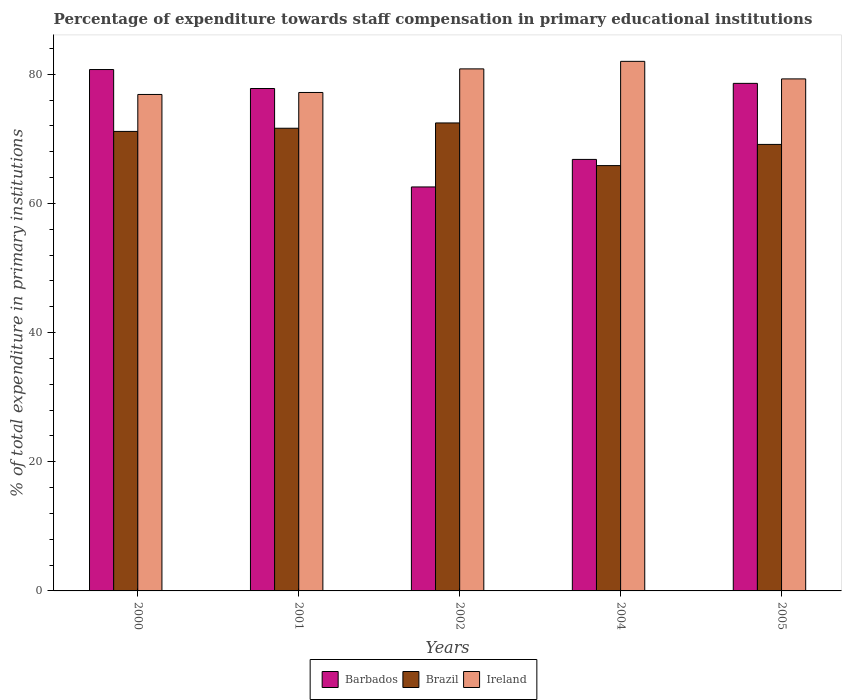How many different coloured bars are there?
Provide a short and direct response. 3. How many groups of bars are there?
Keep it short and to the point. 5. Are the number of bars per tick equal to the number of legend labels?
Provide a succinct answer. Yes. How many bars are there on the 3rd tick from the right?
Offer a very short reply. 3. What is the percentage of expenditure towards staff compensation in Ireland in 2005?
Your answer should be very brief. 79.29. Across all years, what is the maximum percentage of expenditure towards staff compensation in Ireland?
Your answer should be very brief. 82. Across all years, what is the minimum percentage of expenditure towards staff compensation in Brazil?
Offer a terse response. 65.86. In which year was the percentage of expenditure towards staff compensation in Ireland maximum?
Your answer should be compact. 2004. In which year was the percentage of expenditure towards staff compensation in Barbados minimum?
Provide a succinct answer. 2002. What is the total percentage of expenditure towards staff compensation in Ireland in the graph?
Give a very brief answer. 396.19. What is the difference between the percentage of expenditure towards staff compensation in Ireland in 2002 and that in 2005?
Your response must be concise. 1.55. What is the difference between the percentage of expenditure towards staff compensation in Barbados in 2000 and the percentage of expenditure towards staff compensation in Ireland in 2005?
Give a very brief answer. 1.45. What is the average percentage of expenditure towards staff compensation in Brazil per year?
Provide a succinct answer. 70.05. In the year 2001, what is the difference between the percentage of expenditure towards staff compensation in Ireland and percentage of expenditure towards staff compensation in Brazil?
Your response must be concise. 5.54. What is the ratio of the percentage of expenditure towards staff compensation in Brazil in 2004 to that in 2005?
Keep it short and to the point. 0.95. Is the difference between the percentage of expenditure towards staff compensation in Ireland in 2001 and 2004 greater than the difference between the percentage of expenditure towards staff compensation in Brazil in 2001 and 2004?
Ensure brevity in your answer.  No. What is the difference between the highest and the second highest percentage of expenditure towards staff compensation in Barbados?
Keep it short and to the point. 2.14. What is the difference between the highest and the lowest percentage of expenditure towards staff compensation in Brazil?
Keep it short and to the point. 6.6. Is the sum of the percentage of expenditure towards staff compensation in Brazil in 2002 and 2004 greater than the maximum percentage of expenditure towards staff compensation in Ireland across all years?
Provide a succinct answer. Yes. What does the 1st bar from the left in 2005 represents?
Provide a short and direct response. Barbados. How many bars are there?
Your response must be concise. 15. How many years are there in the graph?
Keep it short and to the point. 5. What is the difference between two consecutive major ticks on the Y-axis?
Offer a terse response. 20. Are the values on the major ticks of Y-axis written in scientific E-notation?
Your response must be concise. No. Does the graph contain grids?
Keep it short and to the point. No. Where does the legend appear in the graph?
Provide a short and direct response. Bottom center. How are the legend labels stacked?
Offer a terse response. Horizontal. What is the title of the graph?
Offer a terse response. Percentage of expenditure towards staff compensation in primary educational institutions. What is the label or title of the Y-axis?
Offer a terse response. % of total expenditure in primary institutions. What is the % of total expenditure in primary institutions of Barbados in 2000?
Your answer should be very brief. 80.73. What is the % of total expenditure in primary institutions in Brazil in 2000?
Your answer should be compact. 71.15. What is the % of total expenditure in primary institutions of Ireland in 2000?
Offer a very short reply. 76.88. What is the % of total expenditure in primary institutions in Barbados in 2001?
Ensure brevity in your answer.  77.8. What is the % of total expenditure in primary institutions of Brazil in 2001?
Provide a short and direct response. 71.64. What is the % of total expenditure in primary institutions of Ireland in 2001?
Provide a short and direct response. 77.18. What is the % of total expenditure in primary institutions of Barbados in 2002?
Give a very brief answer. 62.55. What is the % of total expenditure in primary institutions of Brazil in 2002?
Your response must be concise. 72.46. What is the % of total expenditure in primary institutions in Ireland in 2002?
Your answer should be compact. 80.84. What is the % of total expenditure in primary institutions of Barbados in 2004?
Offer a very short reply. 66.82. What is the % of total expenditure in primary institutions of Brazil in 2004?
Your answer should be compact. 65.86. What is the % of total expenditure in primary institutions of Ireland in 2004?
Your response must be concise. 82. What is the % of total expenditure in primary institutions in Barbados in 2005?
Give a very brief answer. 78.59. What is the % of total expenditure in primary institutions in Brazil in 2005?
Your response must be concise. 69.14. What is the % of total expenditure in primary institutions of Ireland in 2005?
Ensure brevity in your answer.  79.29. Across all years, what is the maximum % of total expenditure in primary institutions of Barbados?
Your response must be concise. 80.73. Across all years, what is the maximum % of total expenditure in primary institutions of Brazil?
Provide a succinct answer. 72.46. Across all years, what is the maximum % of total expenditure in primary institutions of Ireland?
Provide a succinct answer. 82. Across all years, what is the minimum % of total expenditure in primary institutions of Barbados?
Your answer should be very brief. 62.55. Across all years, what is the minimum % of total expenditure in primary institutions of Brazil?
Offer a terse response. 65.86. Across all years, what is the minimum % of total expenditure in primary institutions in Ireland?
Ensure brevity in your answer.  76.88. What is the total % of total expenditure in primary institutions in Barbados in the graph?
Provide a short and direct response. 366.5. What is the total % of total expenditure in primary institutions of Brazil in the graph?
Provide a succinct answer. 350.27. What is the total % of total expenditure in primary institutions in Ireland in the graph?
Make the answer very short. 396.19. What is the difference between the % of total expenditure in primary institutions in Barbados in 2000 and that in 2001?
Provide a succinct answer. 2.94. What is the difference between the % of total expenditure in primary institutions of Brazil in 2000 and that in 2001?
Offer a terse response. -0.49. What is the difference between the % of total expenditure in primary institutions in Ireland in 2000 and that in 2001?
Make the answer very short. -0.31. What is the difference between the % of total expenditure in primary institutions in Barbados in 2000 and that in 2002?
Your response must be concise. 18.18. What is the difference between the % of total expenditure in primary institutions of Brazil in 2000 and that in 2002?
Keep it short and to the point. -1.31. What is the difference between the % of total expenditure in primary institutions of Ireland in 2000 and that in 2002?
Ensure brevity in your answer.  -3.96. What is the difference between the % of total expenditure in primary institutions in Barbados in 2000 and that in 2004?
Provide a succinct answer. 13.91. What is the difference between the % of total expenditure in primary institutions of Brazil in 2000 and that in 2004?
Ensure brevity in your answer.  5.29. What is the difference between the % of total expenditure in primary institutions of Ireland in 2000 and that in 2004?
Provide a short and direct response. -5.13. What is the difference between the % of total expenditure in primary institutions in Barbados in 2000 and that in 2005?
Give a very brief answer. 2.14. What is the difference between the % of total expenditure in primary institutions in Brazil in 2000 and that in 2005?
Offer a very short reply. 2.01. What is the difference between the % of total expenditure in primary institutions of Ireland in 2000 and that in 2005?
Ensure brevity in your answer.  -2.41. What is the difference between the % of total expenditure in primary institutions of Barbados in 2001 and that in 2002?
Make the answer very short. 15.24. What is the difference between the % of total expenditure in primary institutions in Brazil in 2001 and that in 2002?
Give a very brief answer. -0.82. What is the difference between the % of total expenditure in primary institutions in Ireland in 2001 and that in 2002?
Provide a succinct answer. -3.65. What is the difference between the % of total expenditure in primary institutions in Barbados in 2001 and that in 2004?
Offer a very short reply. 10.98. What is the difference between the % of total expenditure in primary institutions in Brazil in 2001 and that in 2004?
Offer a very short reply. 5.78. What is the difference between the % of total expenditure in primary institutions in Ireland in 2001 and that in 2004?
Offer a very short reply. -4.82. What is the difference between the % of total expenditure in primary institutions in Barbados in 2001 and that in 2005?
Make the answer very short. -0.8. What is the difference between the % of total expenditure in primary institutions in Brazil in 2001 and that in 2005?
Make the answer very short. 2.5. What is the difference between the % of total expenditure in primary institutions of Ireland in 2001 and that in 2005?
Provide a succinct answer. -2.1. What is the difference between the % of total expenditure in primary institutions of Barbados in 2002 and that in 2004?
Your answer should be compact. -4.26. What is the difference between the % of total expenditure in primary institutions in Brazil in 2002 and that in 2004?
Your answer should be compact. 6.6. What is the difference between the % of total expenditure in primary institutions of Ireland in 2002 and that in 2004?
Provide a short and direct response. -1.17. What is the difference between the % of total expenditure in primary institutions in Barbados in 2002 and that in 2005?
Your response must be concise. -16.04. What is the difference between the % of total expenditure in primary institutions of Brazil in 2002 and that in 2005?
Give a very brief answer. 3.32. What is the difference between the % of total expenditure in primary institutions in Ireland in 2002 and that in 2005?
Ensure brevity in your answer.  1.55. What is the difference between the % of total expenditure in primary institutions in Barbados in 2004 and that in 2005?
Make the answer very short. -11.77. What is the difference between the % of total expenditure in primary institutions in Brazil in 2004 and that in 2005?
Provide a succinct answer. -3.28. What is the difference between the % of total expenditure in primary institutions of Ireland in 2004 and that in 2005?
Keep it short and to the point. 2.72. What is the difference between the % of total expenditure in primary institutions in Barbados in 2000 and the % of total expenditure in primary institutions in Brazil in 2001?
Offer a very short reply. 9.09. What is the difference between the % of total expenditure in primary institutions of Barbados in 2000 and the % of total expenditure in primary institutions of Ireland in 2001?
Offer a very short reply. 3.55. What is the difference between the % of total expenditure in primary institutions in Brazil in 2000 and the % of total expenditure in primary institutions in Ireland in 2001?
Make the answer very short. -6.03. What is the difference between the % of total expenditure in primary institutions of Barbados in 2000 and the % of total expenditure in primary institutions of Brazil in 2002?
Give a very brief answer. 8.27. What is the difference between the % of total expenditure in primary institutions in Barbados in 2000 and the % of total expenditure in primary institutions in Ireland in 2002?
Give a very brief answer. -0.1. What is the difference between the % of total expenditure in primary institutions in Brazil in 2000 and the % of total expenditure in primary institutions in Ireland in 2002?
Your answer should be compact. -9.68. What is the difference between the % of total expenditure in primary institutions in Barbados in 2000 and the % of total expenditure in primary institutions in Brazil in 2004?
Make the answer very short. 14.87. What is the difference between the % of total expenditure in primary institutions in Barbados in 2000 and the % of total expenditure in primary institutions in Ireland in 2004?
Provide a succinct answer. -1.27. What is the difference between the % of total expenditure in primary institutions in Brazil in 2000 and the % of total expenditure in primary institutions in Ireland in 2004?
Provide a short and direct response. -10.85. What is the difference between the % of total expenditure in primary institutions of Barbados in 2000 and the % of total expenditure in primary institutions of Brazil in 2005?
Provide a succinct answer. 11.59. What is the difference between the % of total expenditure in primary institutions of Barbados in 2000 and the % of total expenditure in primary institutions of Ireland in 2005?
Your answer should be compact. 1.45. What is the difference between the % of total expenditure in primary institutions in Brazil in 2000 and the % of total expenditure in primary institutions in Ireland in 2005?
Your answer should be very brief. -8.13. What is the difference between the % of total expenditure in primary institutions in Barbados in 2001 and the % of total expenditure in primary institutions in Brazil in 2002?
Keep it short and to the point. 5.33. What is the difference between the % of total expenditure in primary institutions in Barbados in 2001 and the % of total expenditure in primary institutions in Ireland in 2002?
Your answer should be very brief. -3.04. What is the difference between the % of total expenditure in primary institutions of Brazil in 2001 and the % of total expenditure in primary institutions of Ireland in 2002?
Make the answer very short. -9.19. What is the difference between the % of total expenditure in primary institutions of Barbados in 2001 and the % of total expenditure in primary institutions of Brazil in 2004?
Your answer should be compact. 11.94. What is the difference between the % of total expenditure in primary institutions of Barbados in 2001 and the % of total expenditure in primary institutions of Ireland in 2004?
Keep it short and to the point. -4.2. What is the difference between the % of total expenditure in primary institutions in Brazil in 2001 and the % of total expenditure in primary institutions in Ireland in 2004?
Provide a short and direct response. -10.36. What is the difference between the % of total expenditure in primary institutions in Barbados in 2001 and the % of total expenditure in primary institutions in Brazil in 2005?
Provide a succinct answer. 8.66. What is the difference between the % of total expenditure in primary institutions in Barbados in 2001 and the % of total expenditure in primary institutions in Ireland in 2005?
Give a very brief answer. -1.49. What is the difference between the % of total expenditure in primary institutions of Brazil in 2001 and the % of total expenditure in primary institutions of Ireland in 2005?
Provide a succinct answer. -7.64. What is the difference between the % of total expenditure in primary institutions of Barbados in 2002 and the % of total expenditure in primary institutions of Brazil in 2004?
Provide a succinct answer. -3.31. What is the difference between the % of total expenditure in primary institutions of Barbados in 2002 and the % of total expenditure in primary institutions of Ireland in 2004?
Your response must be concise. -19.45. What is the difference between the % of total expenditure in primary institutions of Brazil in 2002 and the % of total expenditure in primary institutions of Ireland in 2004?
Offer a very short reply. -9.54. What is the difference between the % of total expenditure in primary institutions in Barbados in 2002 and the % of total expenditure in primary institutions in Brazil in 2005?
Give a very brief answer. -6.59. What is the difference between the % of total expenditure in primary institutions of Barbados in 2002 and the % of total expenditure in primary institutions of Ireland in 2005?
Keep it short and to the point. -16.73. What is the difference between the % of total expenditure in primary institutions in Brazil in 2002 and the % of total expenditure in primary institutions in Ireland in 2005?
Provide a succinct answer. -6.82. What is the difference between the % of total expenditure in primary institutions in Barbados in 2004 and the % of total expenditure in primary institutions in Brazil in 2005?
Give a very brief answer. -2.32. What is the difference between the % of total expenditure in primary institutions in Barbados in 2004 and the % of total expenditure in primary institutions in Ireland in 2005?
Give a very brief answer. -12.47. What is the difference between the % of total expenditure in primary institutions of Brazil in 2004 and the % of total expenditure in primary institutions of Ireland in 2005?
Give a very brief answer. -13.43. What is the average % of total expenditure in primary institutions in Barbados per year?
Offer a terse response. 73.3. What is the average % of total expenditure in primary institutions of Brazil per year?
Your answer should be compact. 70.05. What is the average % of total expenditure in primary institutions in Ireland per year?
Offer a very short reply. 79.24. In the year 2000, what is the difference between the % of total expenditure in primary institutions of Barbados and % of total expenditure in primary institutions of Brazil?
Your answer should be very brief. 9.58. In the year 2000, what is the difference between the % of total expenditure in primary institutions of Barbados and % of total expenditure in primary institutions of Ireland?
Ensure brevity in your answer.  3.86. In the year 2000, what is the difference between the % of total expenditure in primary institutions of Brazil and % of total expenditure in primary institutions of Ireland?
Provide a succinct answer. -5.72. In the year 2001, what is the difference between the % of total expenditure in primary institutions in Barbados and % of total expenditure in primary institutions in Brazil?
Keep it short and to the point. 6.15. In the year 2001, what is the difference between the % of total expenditure in primary institutions in Barbados and % of total expenditure in primary institutions in Ireland?
Provide a short and direct response. 0.61. In the year 2001, what is the difference between the % of total expenditure in primary institutions of Brazil and % of total expenditure in primary institutions of Ireland?
Provide a short and direct response. -5.54. In the year 2002, what is the difference between the % of total expenditure in primary institutions in Barbados and % of total expenditure in primary institutions in Brazil?
Offer a terse response. -9.91. In the year 2002, what is the difference between the % of total expenditure in primary institutions in Barbados and % of total expenditure in primary institutions in Ireland?
Offer a terse response. -18.28. In the year 2002, what is the difference between the % of total expenditure in primary institutions of Brazil and % of total expenditure in primary institutions of Ireland?
Ensure brevity in your answer.  -8.37. In the year 2004, what is the difference between the % of total expenditure in primary institutions of Barbados and % of total expenditure in primary institutions of Brazil?
Give a very brief answer. 0.96. In the year 2004, what is the difference between the % of total expenditure in primary institutions in Barbados and % of total expenditure in primary institutions in Ireland?
Your answer should be compact. -15.18. In the year 2004, what is the difference between the % of total expenditure in primary institutions of Brazil and % of total expenditure in primary institutions of Ireland?
Your answer should be compact. -16.14. In the year 2005, what is the difference between the % of total expenditure in primary institutions in Barbados and % of total expenditure in primary institutions in Brazil?
Offer a very short reply. 9.45. In the year 2005, what is the difference between the % of total expenditure in primary institutions in Barbados and % of total expenditure in primary institutions in Ireland?
Provide a succinct answer. -0.69. In the year 2005, what is the difference between the % of total expenditure in primary institutions in Brazil and % of total expenditure in primary institutions in Ireland?
Make the answer very short. -10.14. What is the ratio of the % of total expenditure in primary institutions of Barbados in 2000 to that in 2001?
Make the answer very short. 1.04. What is the ratio of the % of total expenditure in primary institutions in Ireland in 2000 to that in 2001?
Give a very brief answer. 1. What is the ratio of the % of total expenditure in primary institutions of Barbados in 2000 to that in 2002?
Ensure brevity in your answer.  1.29. What is the ratio of the % of total expenditure in primary institutions of Brazil in 2000 to that in 2002?
Offer a terse response. 0.98. What is the ratio of the % of total expenditure in primary institutions in Ireland in 2000 to that in 2002?
Offer a very short reply. 0.95. What is the ratio of the % of total expenditure in primary institutions of Barbados in 2000 to that in 2004?
Provide a succinct answer. 1.21. What is the ratio of the % of total expenditure in primary institutions in Brazil in 2000 to that in 2004?
Give a very brief answer. 1.08. What is the ratio of the % of total expenditure in primary institutions in Ireland in 2000 to that in 2004?
Your answer should be very brief. 0.94. What is the ratio of the % of total expenditure in primary institutions in Barbados in 2000 to that in 2005?
Offer a very short reply. 1.03. What is the ratio of the % of total expenditure in primary institutions in Brazil in 2000 to that in 2005?
Offer a terse response. 1.03. What is the ratio of the % of total expenditure in primary institutions in Ireland in 2000 to that in 2005?
Provide a succinct answer. 0.97. What is the ratio of the % of total expenditure in primary institutions of Barbados in 2001 to that in 2002?
Keep it short and to the point. 1.24. What is the ratio of the % of total expenditure in primary institutions of Brazil in 2001 to that in 2002?
Your answer should be compact. 0.99. What is the ratio of the % of total expenditure in primary institutions of Ireland in 2001 to that in 2002?
Your answer should be very brief. 0.95. What is the ratio of the % of total expenditure in primary institutions of Barbados in 2001 to that in 2004?
Provide a short and direct response. 1.16. What is the ratio of the % of total expenditure in primary institutions in Brazil in 2001 to that in 2004?
Provide a short and direct response. 1.09. What is the ratio of the % of total expenditure in primary institutions in Ireland in 2001 to that in 2004?
Your response must be concise. 0.94. What is the ratio of the % of total expenditure in primary institutions of Barbados in 2001 to that in 2005?
Provide a short and direct response. 0.99. What is the ratio of the % of total expenditure in primary institutions in Brazil in 2001 to that in 2005?
Your answer should be very brief. 1.04. What is the ratio of the % of total expenditure in primary institutions in Ireland in 2001 to that in 2005?
Give a very brief answer. 0.97. What is the ratio of the % of total expenditure in primary institutions in Barbados in 2002 to that in 2004?
Ensure brevity in your answer.  0.94. What is the ratio of the % of total expenditure in primary institutions of Brazil in 2002 to that in 2004?
Provide a short and direct response. 1.1. What is the ratio of the % of total expenditure in primary institutions of Ireland in 2002 to that in 2004?
Ensure brevity in your answer.  0.99. What is the ratio of the % of total expenditure in primary institutions of Barbados in 2002 to that in 2005?
Your response must be concise. 0.8. What is the ratio of the % of total expenditure in primary institutions of Brazil in 2002 to that in 2005?
Your response must be concise. 1.05. What is the ratio of the % of total expenditure in primary institutions of Ireland in 2002 to that in 2005?
Offer a very short reply. 1.02. What is the ratio of the % of total expenditure in primary institutions of Barbados in 2004 to that in 2005?
Ensure brevity in your answer.  0.85. What is the ratio of the % of total expenditure in primary institutions in Brazil in 2004 to that in 2005?
Your response must be concise. 0.95. What is the ratio of the % of total expenditure in primary institutions of Ireland in 2004 to that in 2005?
Your answer should be very brief. 1.03. What is the difference between the highest and the second highest % of total expenditure in primary institutions in Barbados?
Make the answer very short. 2.14. What is the difference between the highest and the second highest % of total expenditure in primary institutions of Brazil?
Provide a succinct answer. 0.82. What is the difference between the highest and the second highest % of total expenditure in primary institutions of Ireland?
Offer a terse response. 1.17. What is the difference between the highest and the lowest % of total expenditure in primary institutions of Barbados?
Provide a succinct answer. 18.18. What is the difference between the highest and the lowest % of total expenditure in primary institutions of Brazil?
Your answer should be very brief. 6.6. What is the difference between the highest and the lowest % of total expenditure in primary institutions in Ireland?
Ensure brevity in your answer.  5.13. 